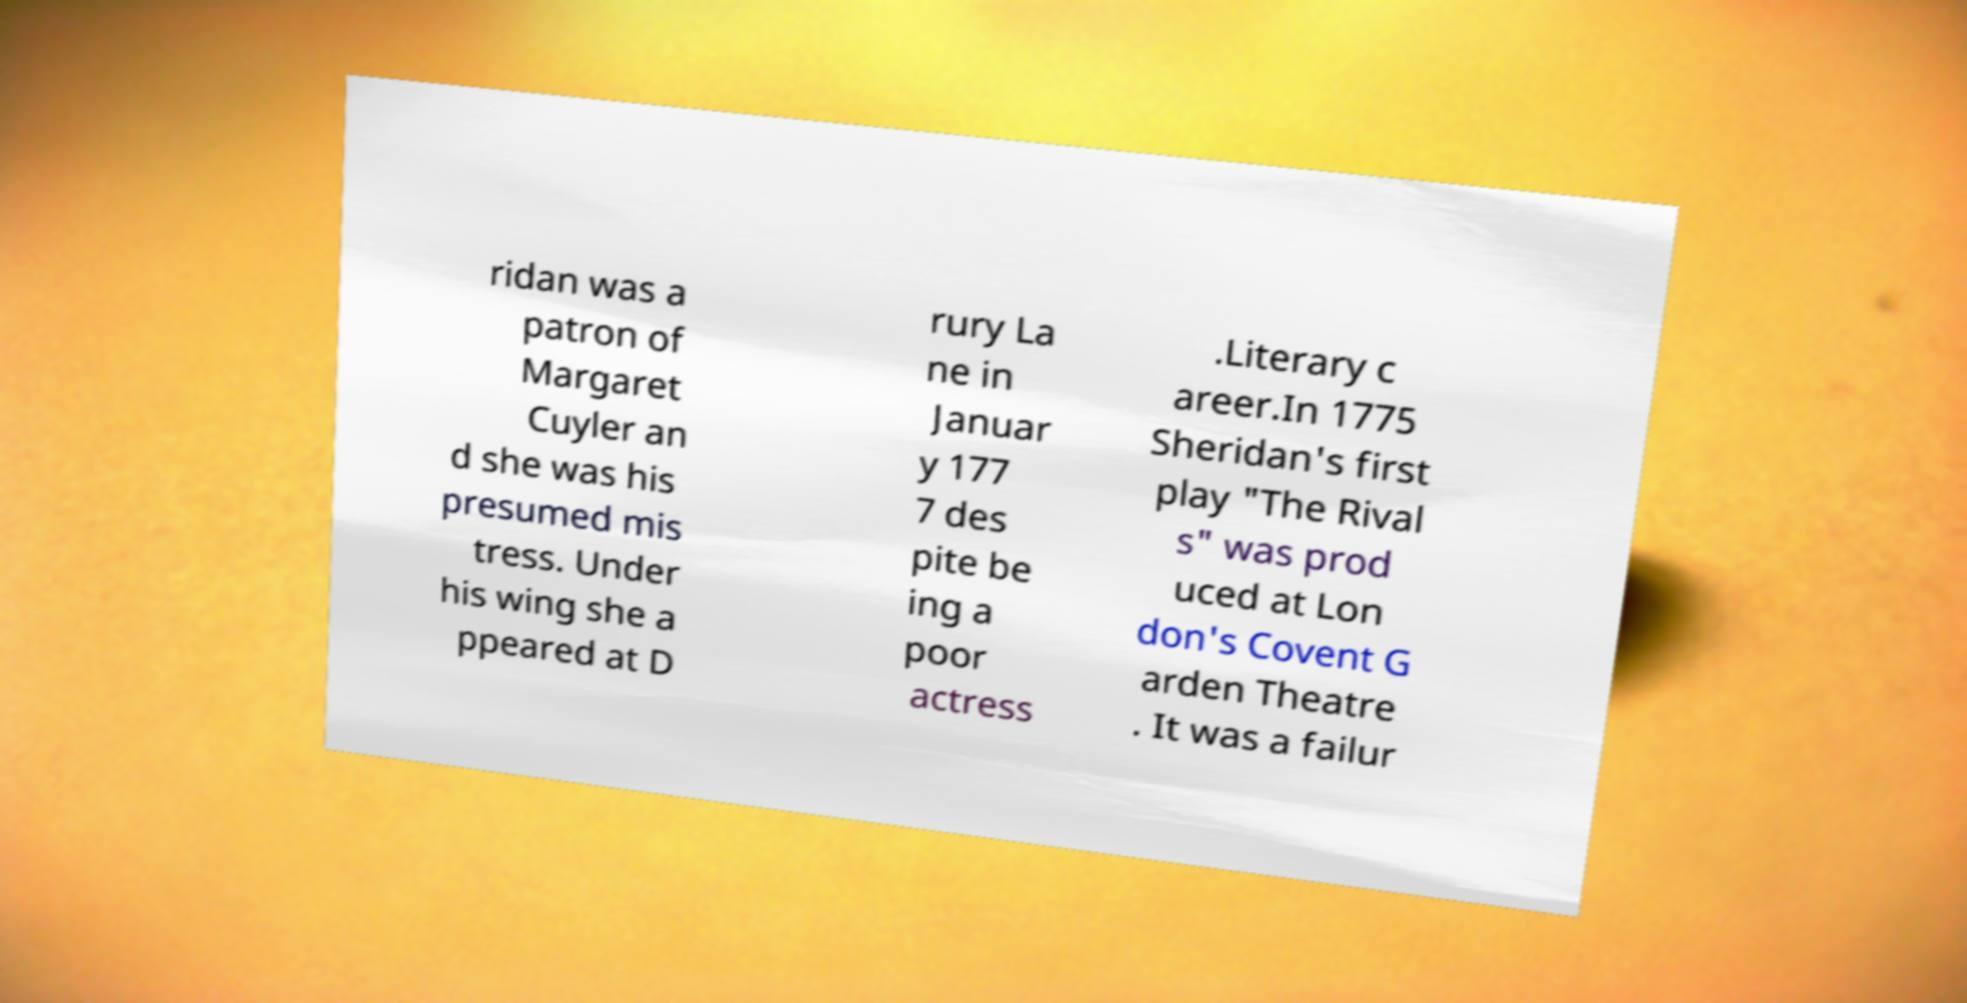For documentation purposes, I need the text within this image transcribed. Could you provide that? ridan was a patron of Margaret Cuyler an d she was his presumed mis tress. Under his wing she a ppeared at D rury La ne in Januar y 177 7 des pite be ing a poor actress .Literary c areer.In 1775 Sheridan's first play "The Rival s" was prod uced at Lon don's Covent G arden Theatre . It was a failur 